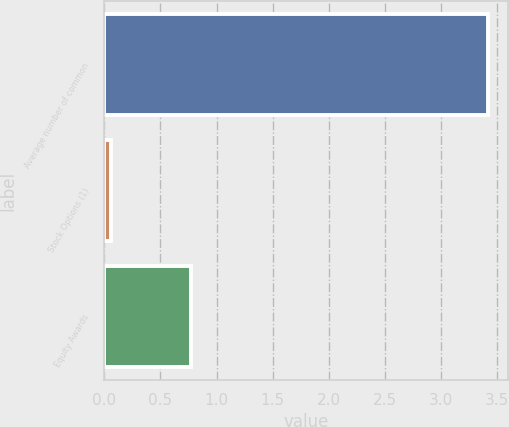<chart> <loc_0><loc_0><loc_500><loc_500><bar_chart><fcel>Average number of common<fcel>Stock Options (1)<fcel>Equity Awards<nl><fcel>3.42<fcel>0.06<fcel>0.77<nl></chart> 